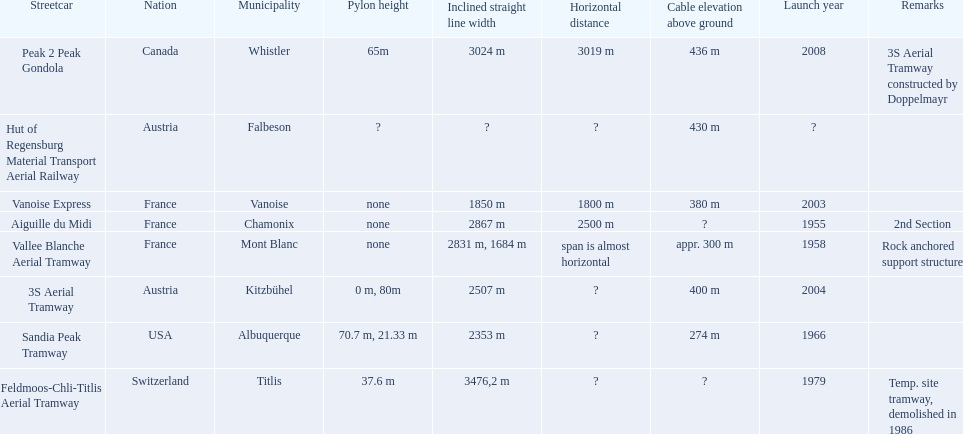Which tramways are in france? Vanoise Express, Aiguille du Midi, Vallee Blanche Aerial Tramway. Which of those were inaugurated in the 1950? Aiguille du Midi, Vallee Blanche Aerial Tramway. I'm looking to parse the entire table for insights. Could you assist me with that? {'header': ['Streetcar', 'Nation', 'Municipality', 'Pylon height', 'Inclined straight line width', 'Horizontal distance', 'Cable elevation above ground', 'Launch year', 'Remarks'], 'rows': [['Peak 2 Peak Gondola', 'Canada', 'Whistler', '65m', '3024 m', '3019 m', '436 m', '2008', '3S Aerial Tramway constructed by Doppelmayr'], ['Hut of Regensburg Material Transport Aerial Railway', 'Austria', 'Falbeson', '?', '?', '?', '430 m', '?', ''], ['Vanoise Express', 'France', 'Vanoise', 'none', '1850 m', '1800 m', '380 m', '2003', ''], ['Aiguille du Midi', 'France', 'Chamonix', 'none', '2867 m', '2500 m', '?', '1955', '2nd Section'], ['Vallee Blanche Aerial Tramway', 'France', 'Mont Blanc', 'none', '2831 m, 1684 m', 'span is almost horizontal', 'appr. 300 m', '1958', 'Rock anchored support structure'], ['3S Aerial Tramway', 'Austria', 'Kitzbühel', '0 m, 80m', '2507 m', '?', '400 m', '2004', ''], ['Sandia Peak Tramway', 'USA', 'Albuquerque', '70.7 m, 21.33 m', '2353 m', '?', '274 m', '1966', ''], ['Feldmoos-Chli-Titlis Aerial Tramway', 'Switzerland', 'Titlis', '37.6 m', '3476,2 m', '?', '?', '1979', 'Temp. site tramway, demolished in 1986']]} Which of these tramways span is not almost horizontal? Aiguille du Midi. 